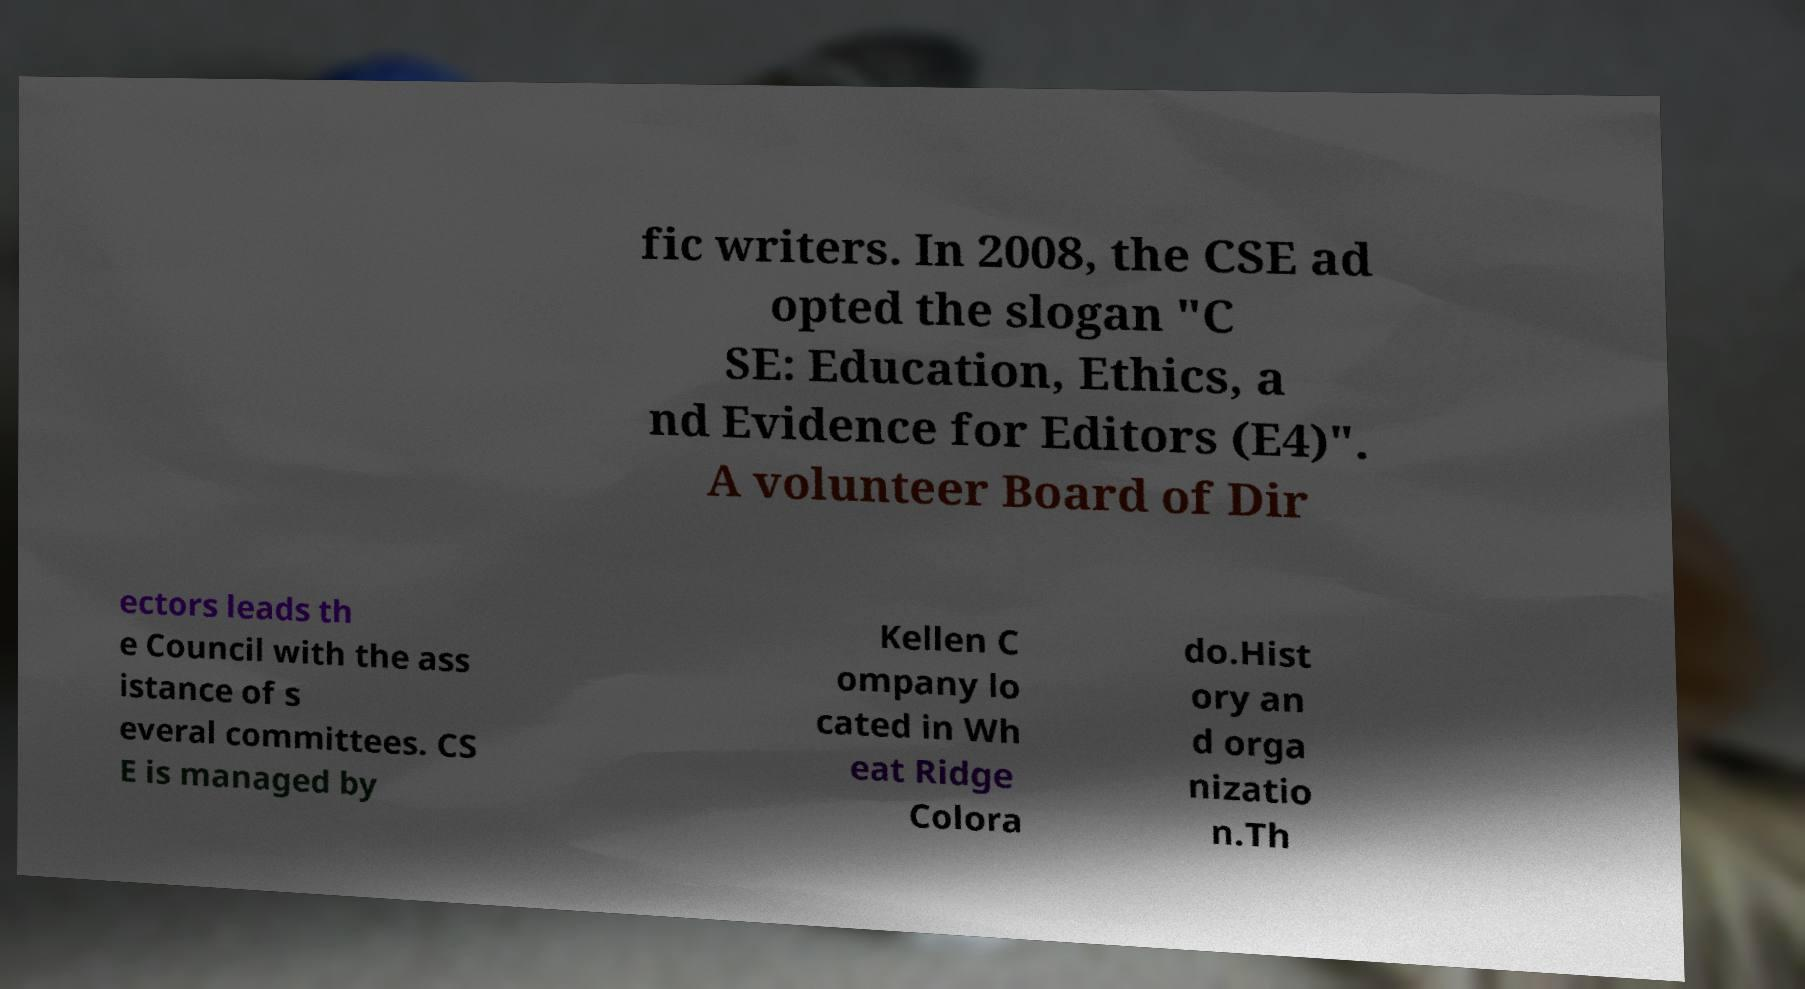For documentation purposes, I need the text within this image transcribed. Could you provide that? fic writers. In 2008, the CSE ad opted the slogan "C SE: Education, Ethics, a nd Evidence for Editors (E4)". A volunteer Board of Dir ectors leads th e Council with the ass istance of s everal committees. CS E is managed by Kellen C ompany lo cated in Wh eat Ridge Colora do.Hist ory an d orga nizatio n.Th 